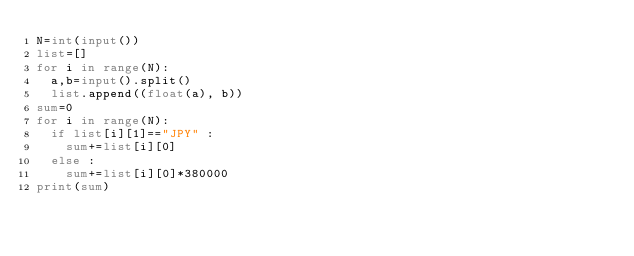Convert code to text. <code><loc_0><loc_0><loc_500><loc_500><_Python_>N=int(input())
list=[]
for i in range(N):
  a,b=input().split()
  list.append((float(a), b))
sum=0
for i in range(N):
  if list[i][1]=="JPY" :
    sum+=list[i][0]
  else :
    sum+=list[i][0]*380000
print(sum)</code> 